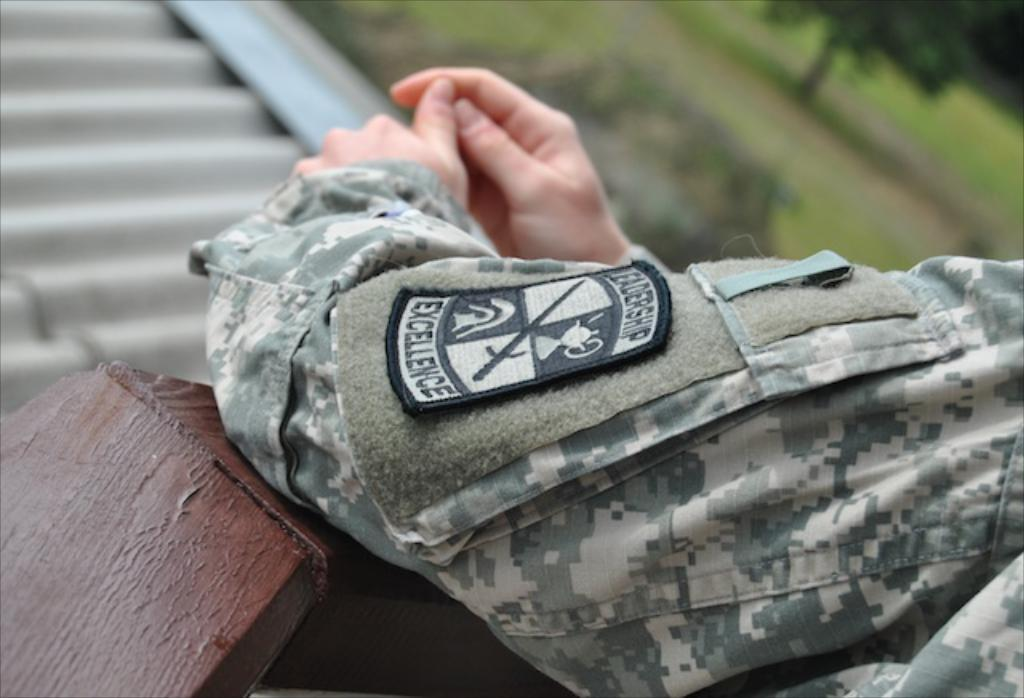What can be seen in the image? There is a person in the image. What part of the person's body is visible? The person's hands are visible. Can you describe the background or surroundings in the image? There are blurred things in front of the person. What type of marble is the person holding in their hand? There is no marble present in the image; the person's hands are visible, but no objects are being held. 